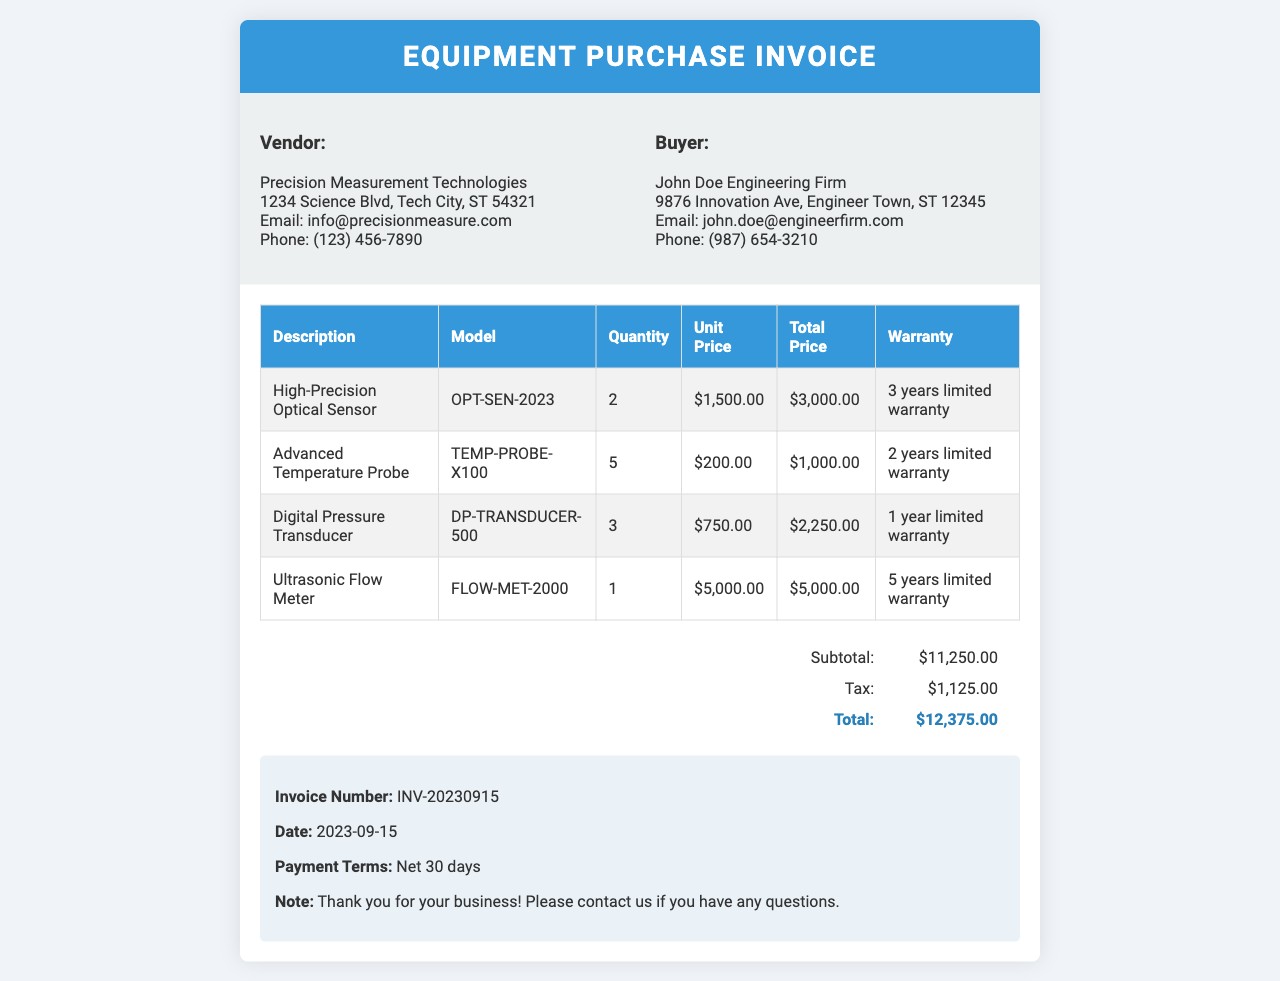What is the vendor's name? The vendor's name is listed in the document's header section under "Vendor."
Answer: Precision Measurement Technologies What is the total amount due? The total amount due is stated in the invoice total section as the final calculated amount.
Answer: $12,375.00 How many High-Precision Optical Sensors were purchased? The quantity purchased is found in the itemized list of products under "Quantity" for the High-Precision Optical Sensor.
Answer: 2 What is the warranty period for the Ultrasonic Flow Meter? The warranty period is specified in the item's row in the invoice under "Warranty" for the Ultrasonic Flow Meter.
Answer: 5 years limited warranty What date was the invoice issued? The invoice issue date is mentioned in the notes section as the date of the invoice.
Answer: 2023-09-15 What is the subtotal before tax? The subtotal is shown in the invoice total section as the amount before tax is applied.
Answer: $11,250.00 Who is the buyer in the invoice? The buyer's name is listed in the document's header section under "Buyer."
Answer: John Doe Engineering Firm How many items are listed on the invoice? The number of items can be counted in the invoice items table, which lists individual items purchased.
Answer: 4 What is the model of the Advanced Temperature Probe? The model is specified in the itemized row under the "Model" column for the Advanced Temperature Probe.
Answer: TEMP-PROBE-X100 